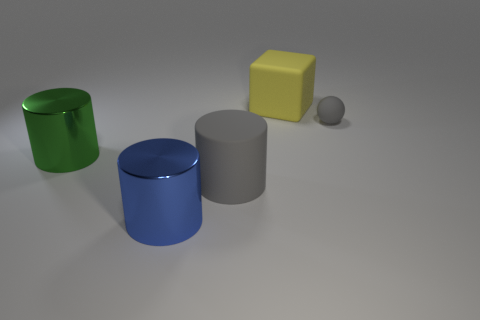Are there an equal number of objects right of the small matte ball and big gray matte cylinders? Upon examination of the image, it appears that there are two objects situated to the right of the small matte ball—a large green cylinder and a smaller yellow cube. In contrast, there is only one object to the right of the big gray matte cylinders, which is a large blue cylinder. Therefore, the number of objects to the right of the small matte ball is not equal to the number of objects to the right of the big gray matte cylinders; there are more objects on the former's side. 